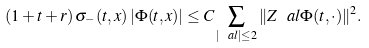<formula> <loc_0><loc_0><loc_500><loc_500>( 1 + t + r ) \, \sigma _ { - } ( t , x ) \, | \Phi ( t , x ) | \leq C \sum _ { | \ a l | \leq 2 } \| Z ^ { \ } a l \Phi ( t , \cdot ) \| ^ { 2 } .</formula> 